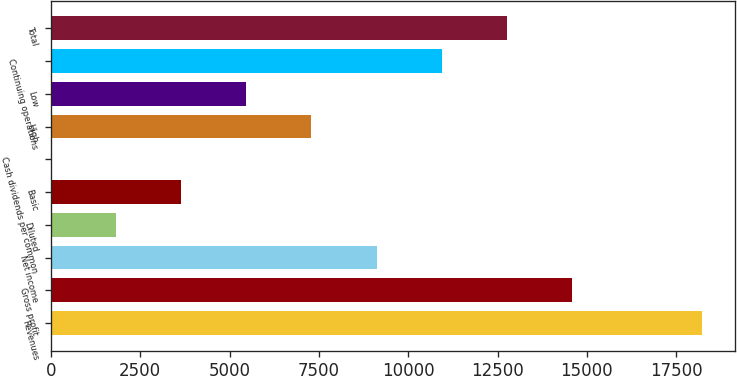<chart> <loc_0><loc_0><loc_500><loc_500><bar_chart><fcel>Revenues<fcel>Gross profit<fcel>Net income<fcel>Diluted<fcel>Basic<fcel>Cash dividends per common<fcel>High<fcel>Low<fcel>Continuing operations<fcel>Total<nl><fcel>18231.9<fcel>14585.5<fcel>9115.96<fcel>1823.24<fcel>3646.42<fcel>0.06<fcel>7292.78<fcel>5469.6<fcel>10939.1<fcel>12762.3<nl></chart> 